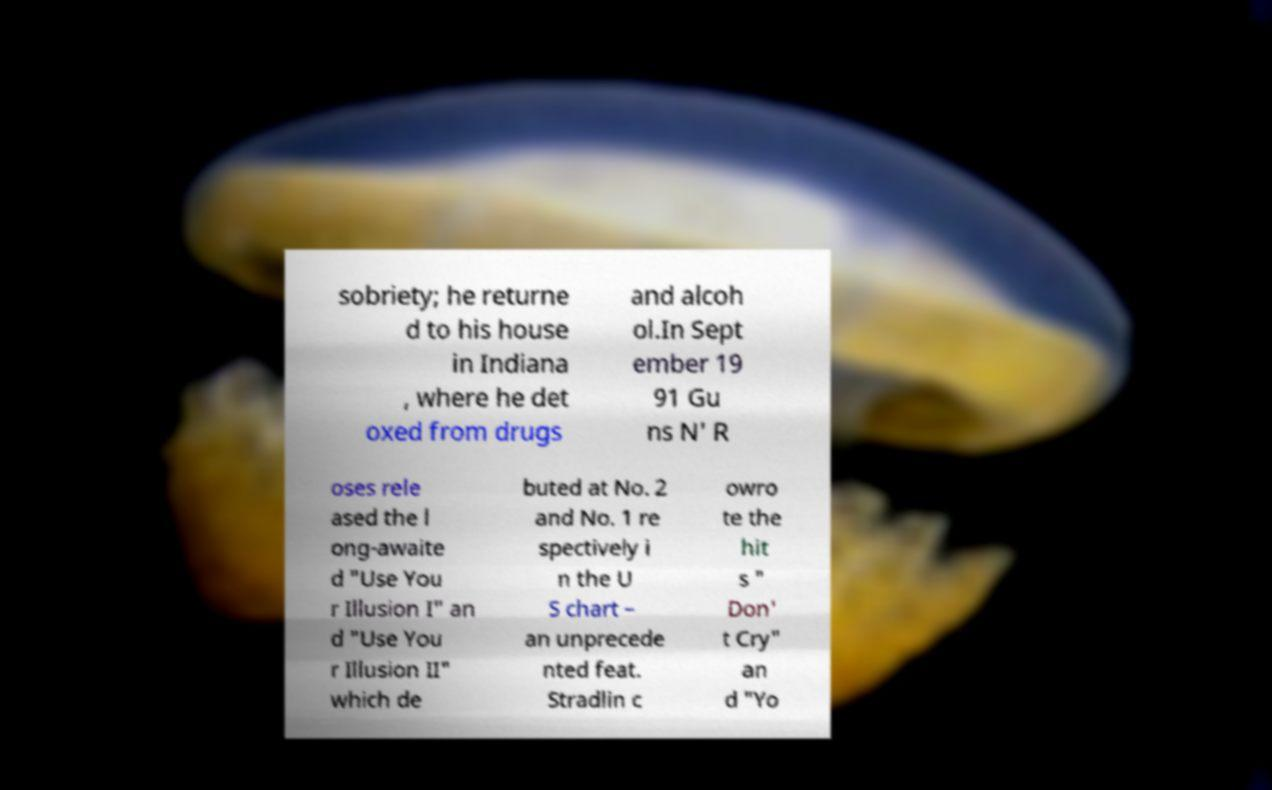I need the written content from this picture converted into text. Can you do that? sobriety; he returne d to his house in Indiana , where he det oxed from drugs and alcoh ol.In Sept ember 19 91 Gu ns N' R oses rele ased the l ong-awaite d "Use You r Illusion I" an d "Use You r Illusion II" which de buted at No. 2 and No. 1 re spectively i n the U S chart – an unprecede nted feat. Stradlin c owro te the hit s " Don' t Cry" an d "Yo 